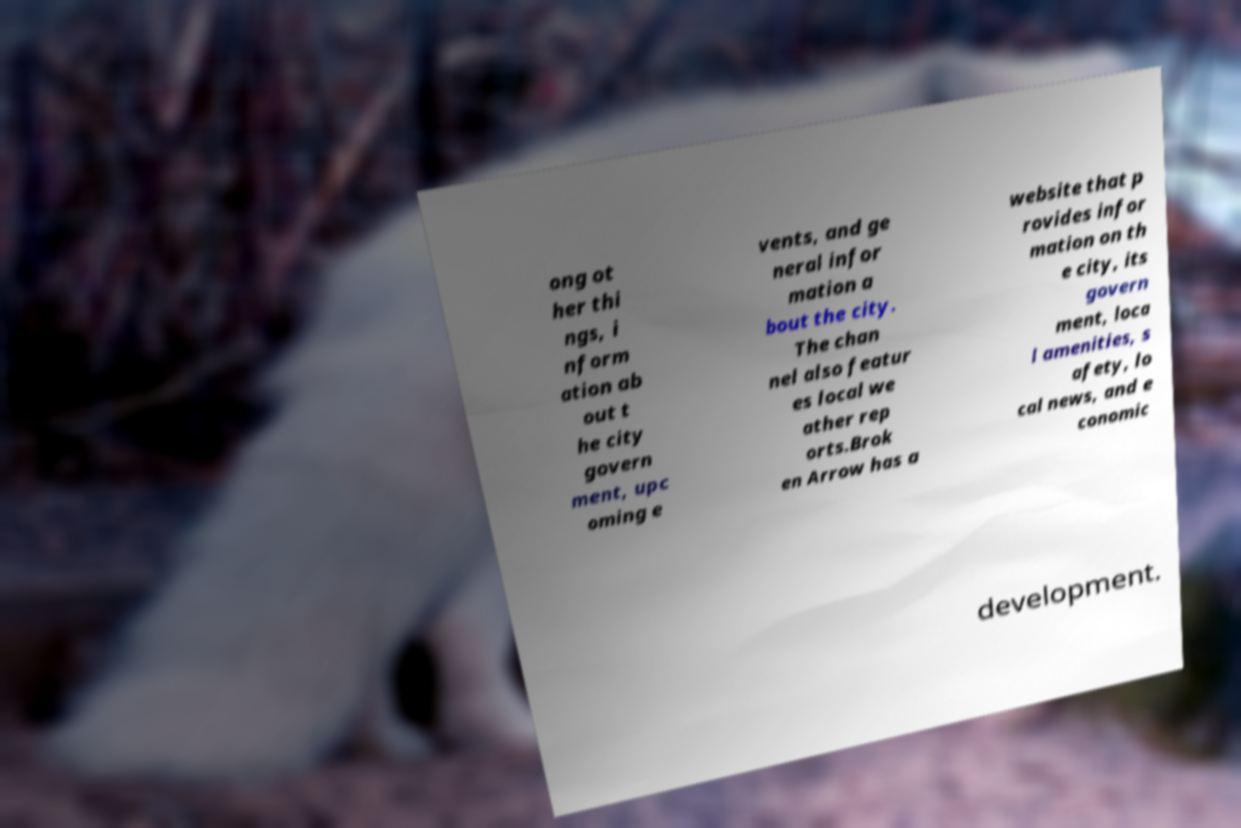Could you assist in decoding the text presented in this image and type it out clearly? ong ot her thi ngs, i nform ation ab out t he city govern ment, upc oming e vents, and ge neral infor mation a bout the city. The chan nel also featur es local we ather rep orts.Brok en Arrow has a website that p rovides infor mation on th e city, its govern ment, loca l amenities, s afety, lo cal news, and e conomic development. 